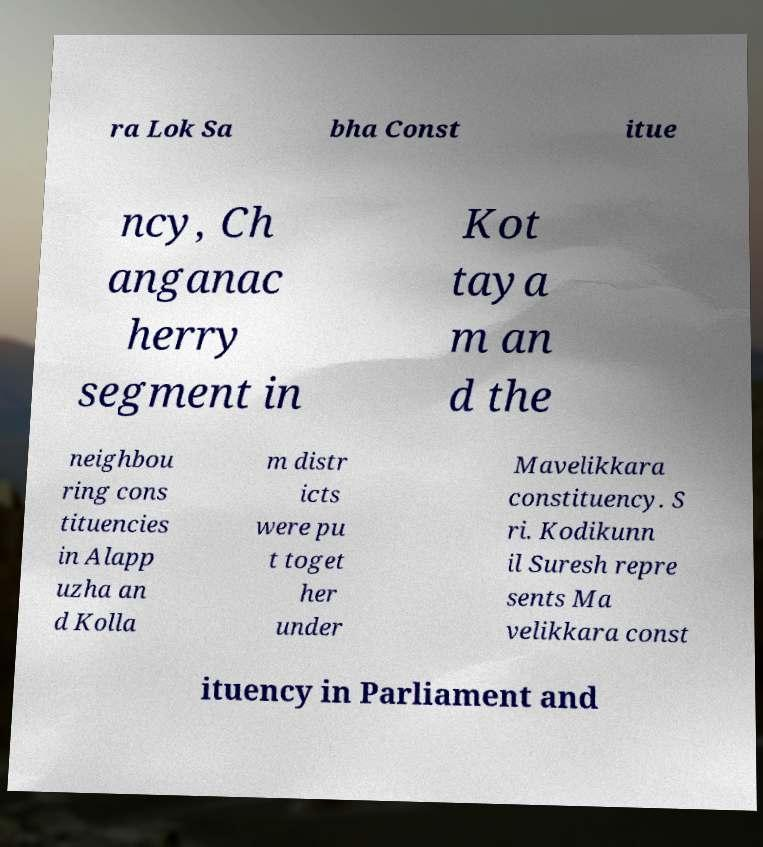Can you read and provide the text displayed in the image?This photo seems to have some interesting text. Can you extract and type it out for me? ra Lok Sa bha Const itue ncy, Ch anganac herry segment in Kot taya m an d the neighbou ring cons tituencies in Alapp uzha an d Kolla m distr icts were pu t toget her under Mavelikkara constituency. S ri. Kodikunn il Suresh repre sents Ma velikkara const ituency in Parliament and 